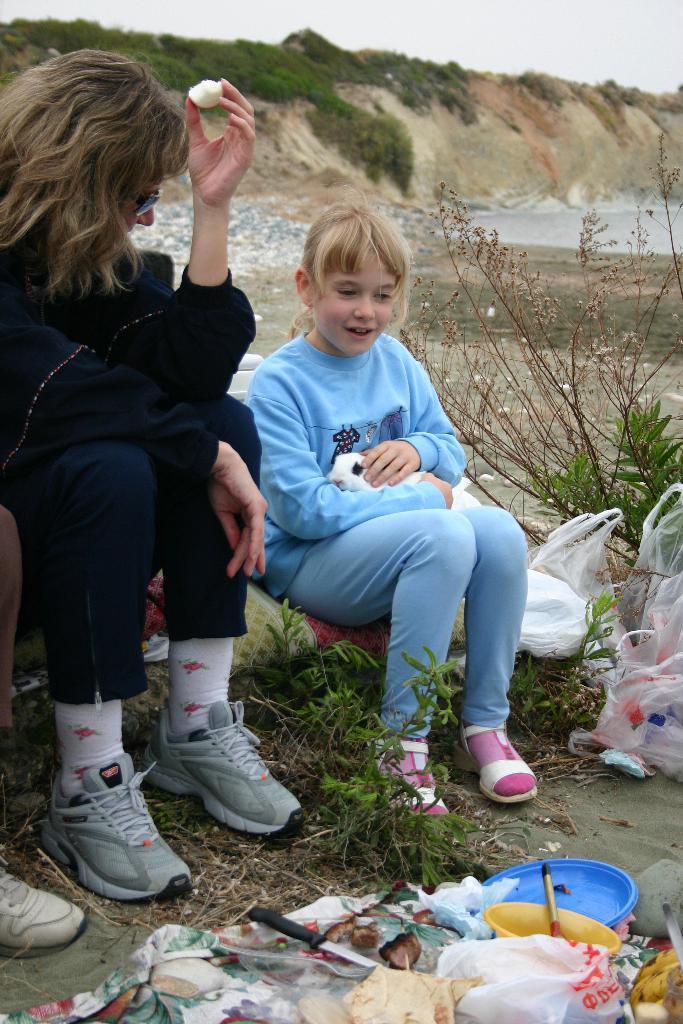How would you summarize this image in a sentence or two? In the picture I can see a woman on the left side and looks like she is holding a food item in her left hand. I can see a girl sitting on the pillow and she is holding an animal. It is looking like a water pool on the top right side. I can see the plastic bowls, a knife and plastic covers on the ground at the bottom of the picture. In the background, I can see the rocks and there is a green grass on the rocks. 